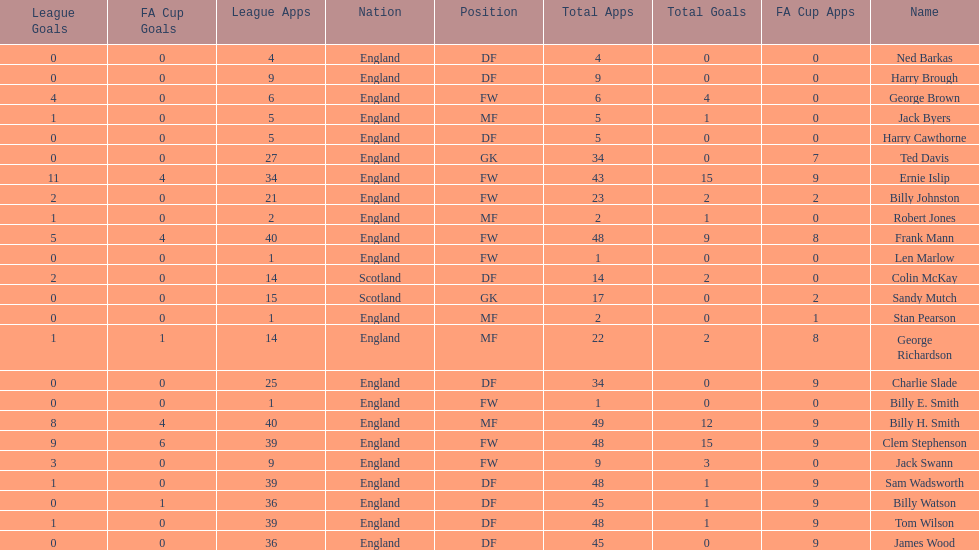Which position is listed the least amount of times on this chart? GK. 